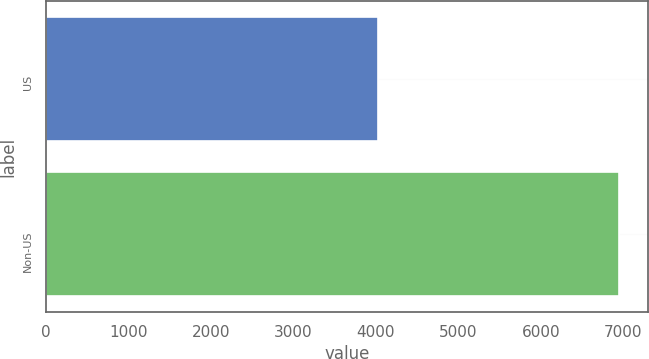<chart> <loc_0><loc_0><loc_500><loc_500><bar_chart><fcel>US<fcel>Non-US<nl><fcel>4027<fcel>6947<nl></chart> 